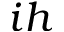Convert formula to latex. <formula><loc_0><loc_0><loc_500><loc_500>i h</formula> 